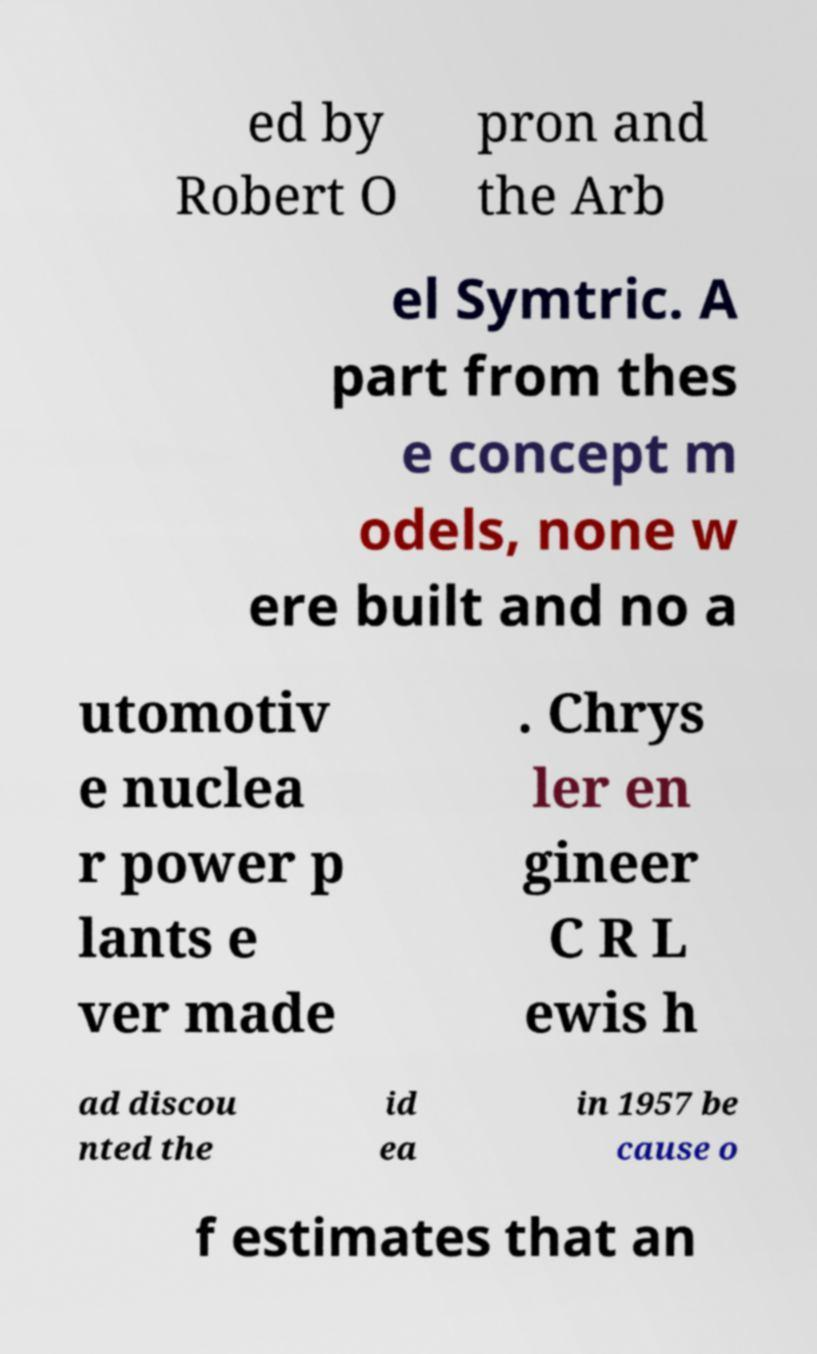Please read and relay the text visible in this image. What does it say? ed by Robert O pron and the Arb el Symtric. A part from thes e concept m odels, none w ere built and no a utomotiv e nuclea r power p lants e ver made . Chrys ler en gineer C R L ewis h ad discou nted the id ea in 1957 be cause o f estimates that an 